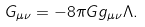Convert formula to latex. <formula><loc_0><loc_0><loc_500><loc_500>G _ { \mu \nu } = - 8 \pi G g _ { \mu \nu } \Lambda .</formula> 